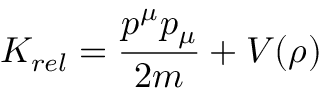Convert formula to latex. <formula><loc_0><loc_0><loc_500><loc_500>K _ { r e l } = { \frac { p ^ { \mu } p _ { \mu } } { 2 m } } + V ( \rho )</formula> 